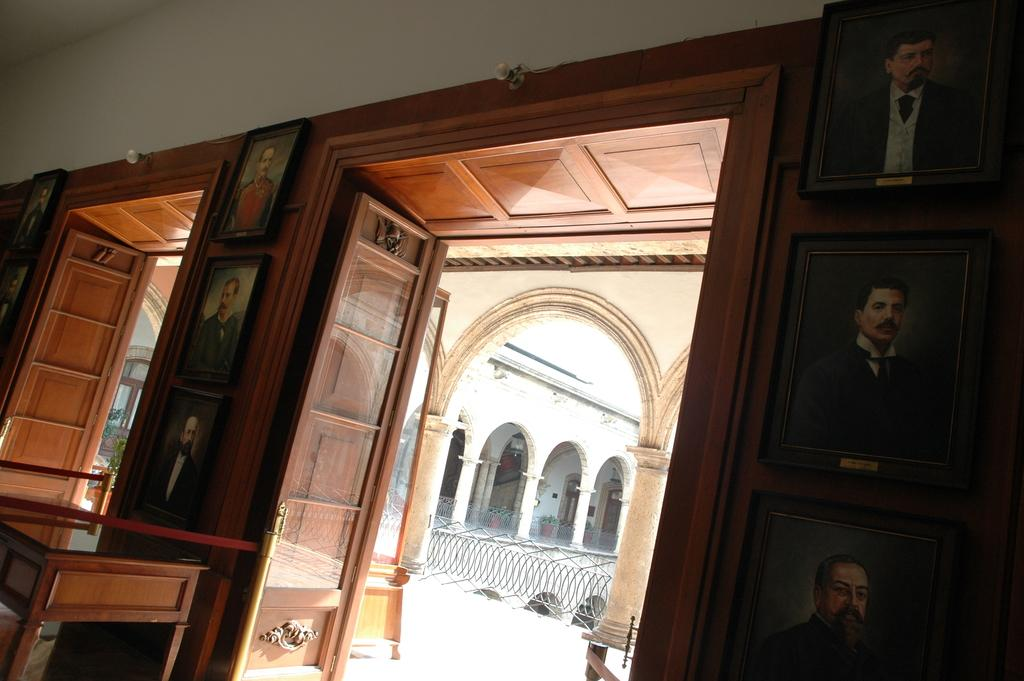What can be seen hanging on the wall in the image? There are photo frames on the wall. What is located on the left side of the image? There is a table on the left side. Are there any openings visible in the image? Yes, there are doors visible in the image. What architectural features can be seen in the background of the image? There are pillars and a fence in the background. What type of riddle is being solved by the mouth in the image? There is no mouth or riddle present in the image. Can you describe the garden visible in the image? There is no garden present in the image. 